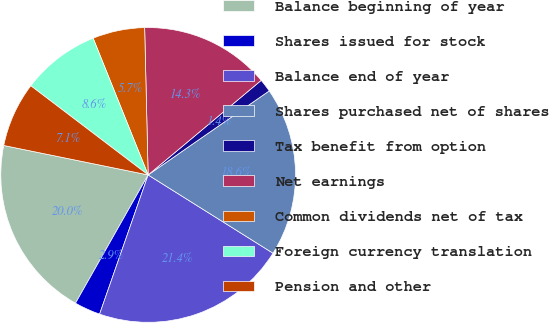<chart> <loc_0><loc_0><loc_500><loc_500><pie_chart><fcel>Balance beginning of year<fcel>Shares issued for stock<fcel>Balance end of year<fcel>Shares purchased net of shares<fcel>Tax benefit from option<fcel>Net earnings<fcel>Common dividends net of tax<fcel>Foreign currency translation<fcel>Pension and other<nl><fcel>20.0%<fcel>2.86%<fcel>21.43%<fcel>18.57%<fcel>1.43%<fcel>14.29%<fcel>5.71%<fcel>8.57%<fcel>7.14%<nl></chart> 